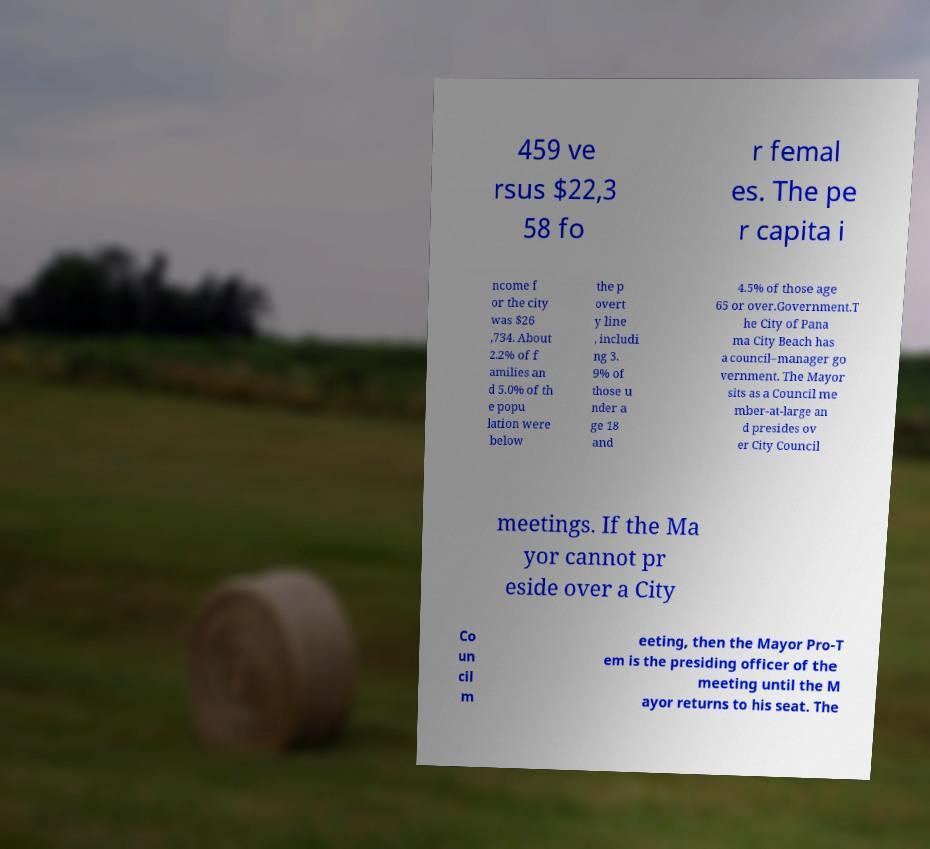Please read and relay the text visible in this image. What does it say? 459 ve rsus $22,3 58 fo r femal es. The pe r capita i ncome f or the city was $26 ,734. About 2.2% of f amilies an d 5.0% of th e popu lation were below the p overt y line , includi ng 3. 9% of those u nder a ge 18 and 4.5% of those age 65 or over.Government.T he City of Pana ma City Beach has a council–manager go vernment. The Mayor sits as a Council me mber-at-large an d presides ov er City Council meetings. If the Ma yor cannot pr eside over a City Co un cil m eeting, then the Mayor Pro-T em is the presiding officer of the meeting until the M ayor returns to his seat. The 